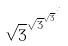<formula> <loc_0><loc_0><loc_500><loc_500>\sqrt { 3 } ^ { \sqrt { 3 } ^ { \sqrt { 3 } ^ { \cdot ^ { \cdot ^ { \cdot } } } } }</formula> 